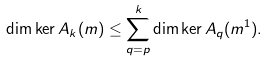<formula> <loc_0><loc_0><loc_500><loc_500>\dim \ker A _ { k } ( m ) \leq \sum _ { q = p } ^ { k } \dim \ker A _ { q } ( m ^ { 1 } ) .</formula> 